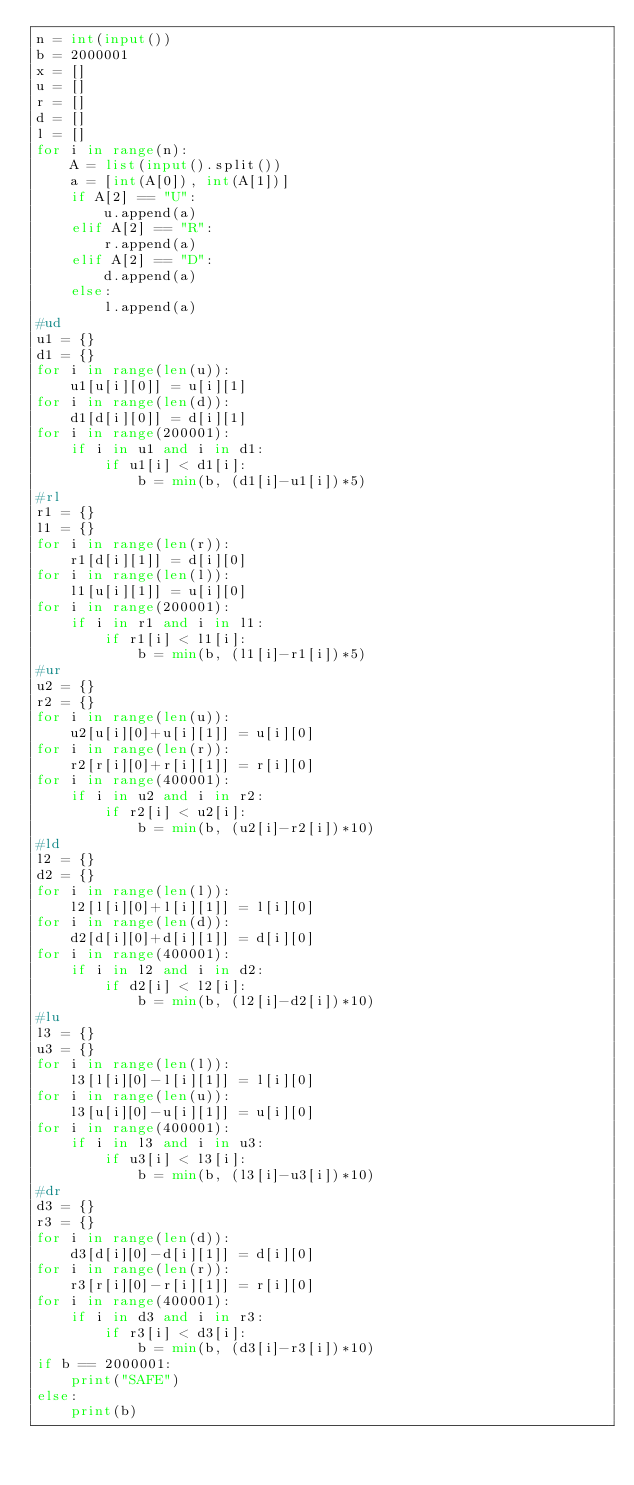<code> <loc_0><loc_0><loc_500><loc_500><_Python_>n = int(input())
b = 2000001
x = []
u = []
r = []
d = []
l = []
for i in range(n):
    A = list(input().split())
    a = [int(A[0]), int(A[1])]
    if A[2] == "U":
        u.append(a)
    elif A[2] == "R":
        r.append(a)
    elif A[2] == "D":
        d.append(a)
    else:
        l.append(a)
#ud
u1 = {}
d1 = {}
for i in range(len(u)):
    u1[u[i][0]] = u[i][1]
for i in range(len(d)):
    d1[d[i][0]] = d[i][1]
for i in range(200001):
    if i in u1 and i in d1:
        if u1[i] < d1[i]:
            b = min(b, (d1[i]-u1[i])*5)
#rl
r1 = {}
l1 = {}
for i in range(len(r)):
    r1[d[i][1]] = d[i][0]
for i in range(len(l)):
    l1[u[i][1]] = u[i][0]
for i in range(200001):
    if i in r1 and i in l1:
        if r1[i] < l1[i]:
            b = min(b, (l1[i]-r1[i])*5)
#ur
u2 = {}
r2 = {}
for i in range(len(u)):
    u2[u[i][0]+u[i][1]] = u[i][0]
for i in range(len(r)):
    r2[r[i][0]+r[i][1]] = r[i][0]
for i in range(400001):
    if i in u2 and i in r2:
        if r2[i] < u2[i]:
            b = min(b, (u2[i]-r2[i])*10)
#ld
l2 = {}
d2 = {}
for i in range(len(l)):
    l2[l[i][0]+l[i][1]] = l[i][0]
for i in range(len(d)):
    d2[d[i][0]+d[i][1]] = d[i][0]
for i in range(400001):
    if i in l2 and i in d2:
        if d2[i] < l2[i]:
            b = min(b, (l2[i]-d2[i])*10)
#lu
l3 = {}
u3 = {}
for i in range(len(l)):
    l3[l[i][0]-l[i][1]] = l[i][0]
for i in range(len(u)):
    l3[u[i][0]-u[i][1]] = u[i][0]
for i in range(400001):
    if i in l3 and i in u3:
        if u3[i] < l3[i]:
            b = min(b, (l3[i]-u3[i])*10)
#dr
d3 = {}
r3 = {}
for i in range(len(d)):
    d3[d[i][0]-d[i][1]] = d[i][0]
for i in range(len(r)):
    r3[r[i][0]-r[i][1]] = r[i][0]
for i in range(400001):
    if i in d3 and i in r3:
        if r3[i] < d3[i]:
            b = min(b, (d3[i]-r3[i])*10)
if b == 2000001:
    print("SAFE")
else:
    print(b)</code> 